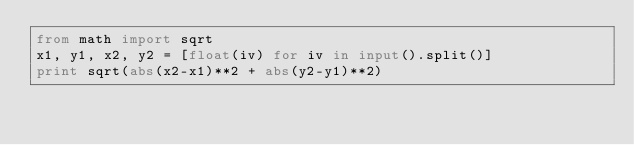Convert code to text. <code><loc_0><loc_0><loc_500><loc_500><_Python_>from math import sqrt
x1, y1, x2, y2 = [float(iv) for iv in input().split()]
print sqrt(abs(x2-x1)**2 + abs(y2-y1)**2)</code> 